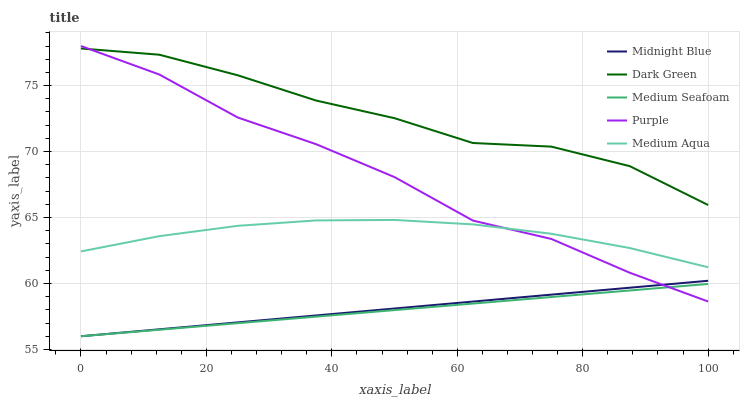Does Medium Seafoam have the minimum area under the curve?
Answer yes or no. Yes. Does Dark Green have the maximum area under the curve?
Answer yes or no. Yes. Does Medium Aqua have the minimum area under the curve?
Answer yes or no. No. Does Medium Aqua have the maximum area under the curve?
Answer yes or no. No. Is Medium Seafoam the smoothest?
Answer yes or no. Yes. Is Purple the roughest?
Answer yes or no. Yes. Is Medium Aqua the smoothest?
Answer yes or no. No. Is Medium Aqua the roughest?
Answer yes or no. No. Does Medium Seafoam have the lowest value?
Answer yes or no. Yes. Does Medium Aqua have the lowest value?
Answer yes or no. No. Does Purple have the highest value?
Answer yes or no. Yes. Does Medium Aqua have the highest value?
Answer yes or no. No. Is Medium Aqua less than Dark Green?
Answer yes or no. Yes. Is Medium Aqua greater than Midnight Blue?
Answer yes or no. Yes. Does Dark Green intersect Purple?
Answer yes or no. Yes. Is Dark Green less than Purple?
Answer yes or no. No. Is Dark Green greater than Purple?
Answer yes or no. No. Does Medium Aqua intersect Dark Green?
Answer yes or no. No. 